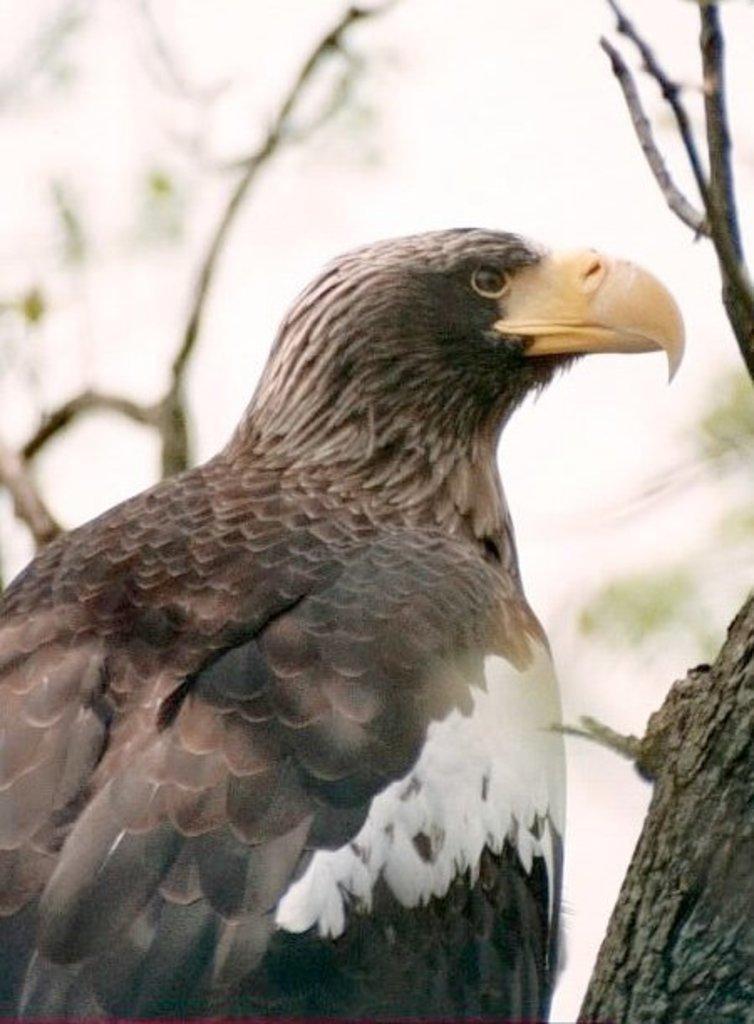Please provide a concise description of this image. In the image there is an eagle with black and white color. And the eagle beak is in yellow color. In the background there are branches. 